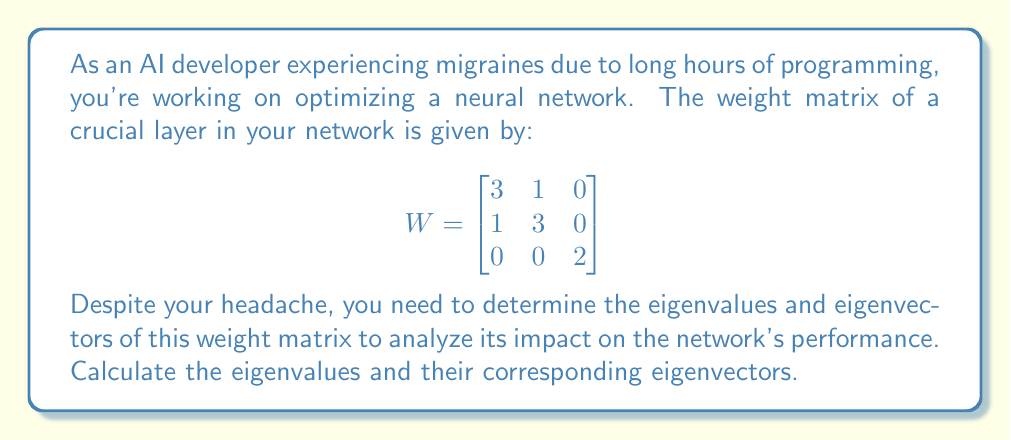Give your solution to this math problem. To find the eigenvalues and eigenvectors of the weight matrix $W$, we'll follow these steps:

1) First, let's find the eigenvalues by solving the characteristic equation:
   $$det(W - \lambda I) = 0$$

   Where $I$ is the 3x3 identity matrix and $\lambda$ represents the eigenvalues.

2) Expanding the determinant:
   $$det\begin{pmatrix}
   3-\lambda & 1 & 0 \\
   1 & 3-\lambda & 0 \\
   0 & 0 & 2-\lambda
   \end{pmatrix} = 0$$

3) This gives us:
   $$(3-\lambda)^2 - 1^2)(2-\lambda) = 0$$
   $$(9-6\lambda+\lambda^2-1)(2-\lambda) = 0$$
   $$(\lambda^2-6\lambda+8)(2-\lambda) = 0$$
   $$(\lambda-4)(\lambda-2)(2-\lambda) = 0$$

4) Solving this equation, we get the eigenvalues:
   $\lambda_1 = 4$, $\lambda_2 = 2$, $\lambda_3 = 2$

5) Now, for each eigenvalue, we need to find the corresponding eigenvector $v$ that satisfies:
   $$(W - \lambda I)v = 0$$

6) For $\lambda_1 = 4$:
   $$\begin{pmatrix}
   -1 & 1 & 0 \\
   1 & -1 & 0 \\
   0 & 0 & -2
   \end{pmatrix}\begin{pmatrix}
   x \\ y \\ z
   \end{pmatrix} = \begin{pmatrix}
   0 \\ 0 \\ 0
   \end{pmatrix}$$

   This gives us: $x = y$, $z = 0$
   So, $v_1 = k\begin{pmatrix} 1 \\ 1 \\ 0 \end{pmatrix}$, where $k$ is any non-zero constant.

7) For $\lambda_2 = \lambda_3 = 2$:
   $$\begin{pmatrix}
   1 & 1 & 0 \\
   1 & 1 & 0 \\
   0 & 0 & 0
   \end{pmatrix}\begin{pmatrix}
   x \\ y \\ z
   \end{pmatrix} = \begin{pmatrix}
   0 \\ 0 \\ 0
   \end{pmatrix}$$

   This gives us: $x = -y$, $z$ can be any value
   So, $v_2 = k\begin{pmatrix} 1 \\ -1 \\ 0 \end{pmatrix}$ and $v_3 = k\begin{pmatrix} 0 \\ 0 \\ 1 \end{pmatrix}$, where $k$ is any non-zero constant.
Answer: Eigenvalues: $\lambda_1 = 4$, $\lambda_2 = 2$, $\lambda_3 = 2$

Corresponding eigenvectors:
$v_1 = k\begin{pmatrix} 1 \\ 1 \\ 0 \end{pmatrix}$, 
$v_2 = k\begin{pmatrix} 1 \\ -1 \\ 0 \end{pmatrix}$, 
$v_3 = k\begin{pmatrix} 0 \\ 0 \\ 1 \end{pmatrix}$, 
where $k$ is any non-zero constant. 